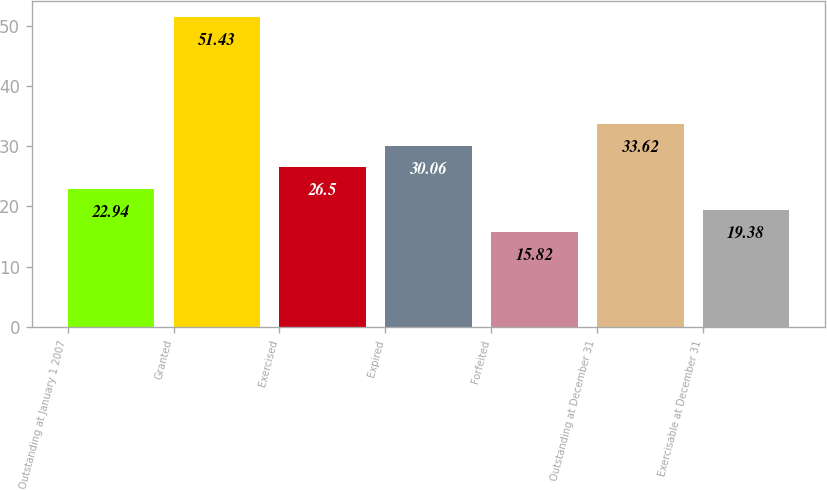<chart> <loc_0><loc_0><loc_500><loc_500><bar_chart><fcel>Outstanding at January 1 2007<fcel>Granted<fcel>Exercised<fcel>Expired<fcel>Forfeited<fcel>Outstanding at December 31<fcel>Exercisable at December 31<nl><fcel>22.94<fcel>51.43<fcel>26.5<fcel>30.06<fcel>15.82<fcel>33.62<fcel>19.38<nl></chart> 